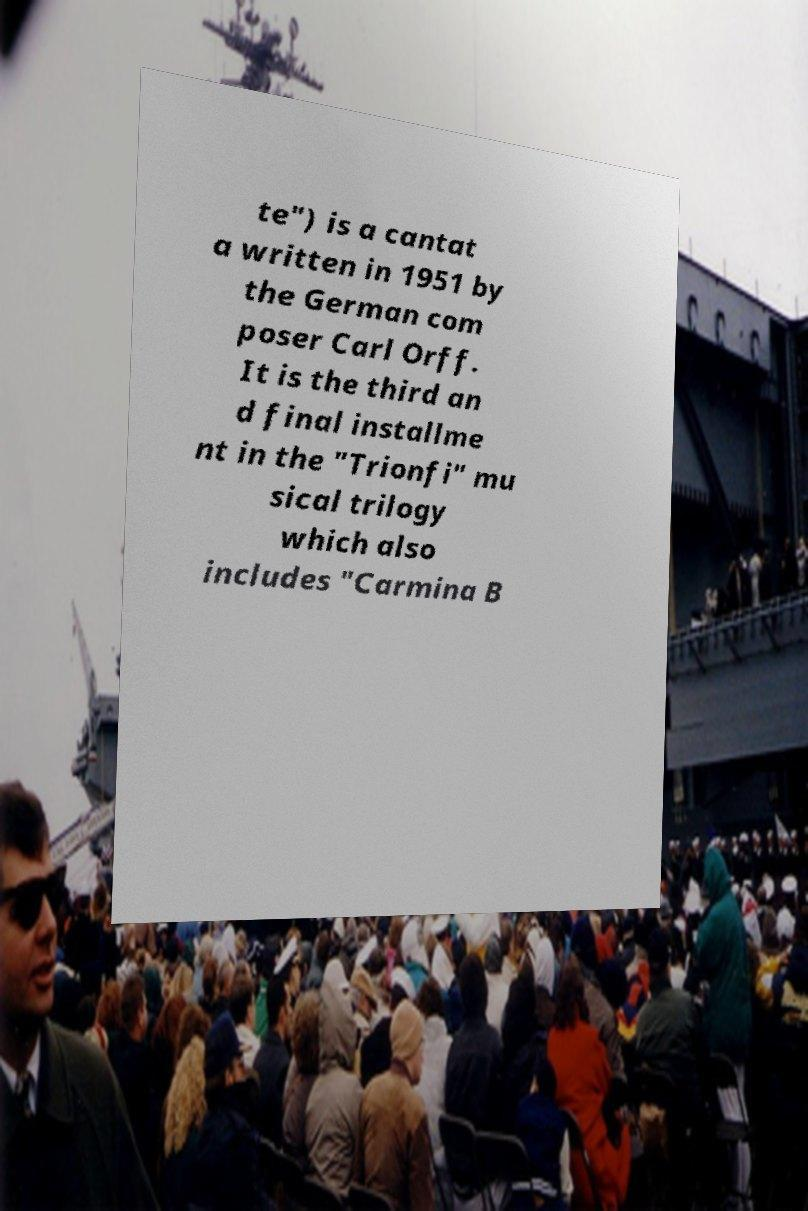Could you assist in decoding the text presented in this image and type it out clearly? te") is a cantat a written in 1951 by the German com poser Carl Orff. It is the third an d final installme nt in the "Trionfi" mu sical trilogy which also includes "Carmina B 